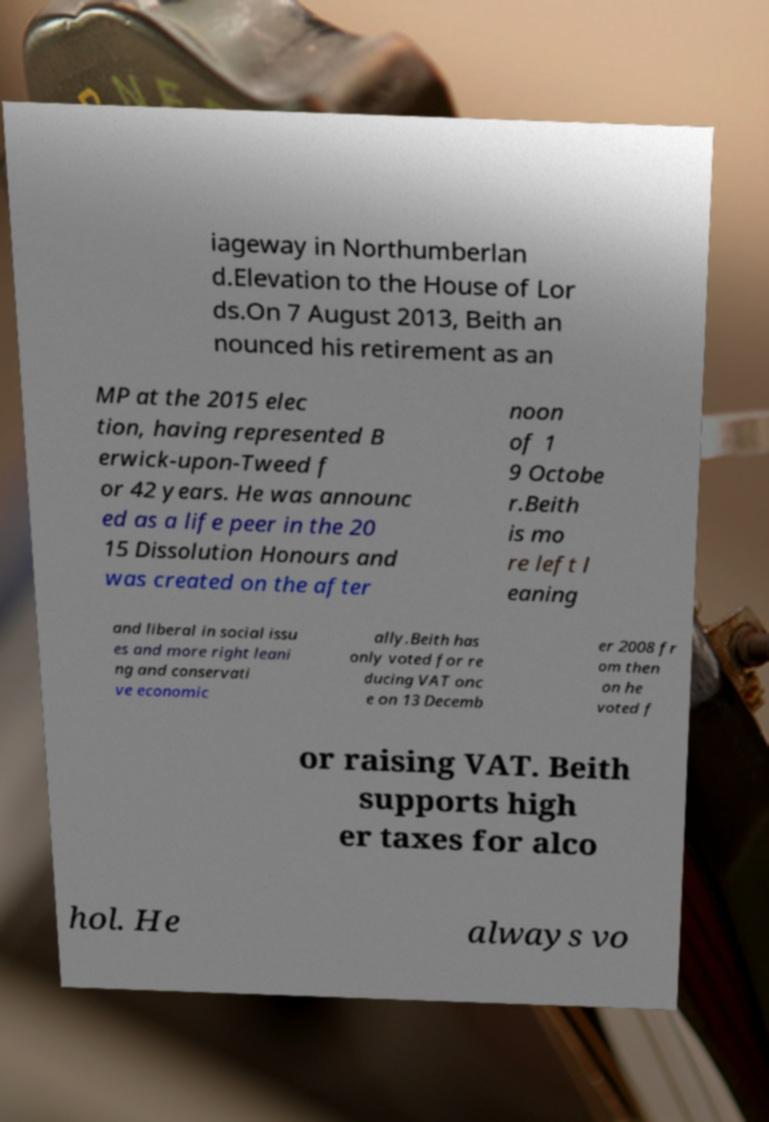I need the written content from this picture converted into text. Can you do that? iageway in Northumberlan d.Elevation to the House of Lor ds.On 7 August 2013, Beith an nounced his retirement as an MP at the 2015 elec tion, having represented B erwick-upon-Tweed f or 42 years. He was announc ed as a life peer in the 20 15 Dissolution Honours and was created on the after noon of 1 9 Octobe r.Beith is mo re left l eaning and liberal in social issu es and more right leani ng and conservati ve economic ally.Beith has only voted for re ducing VAT onc e on 13 Decemb er 2008 fr om then on he voted f or raising VAT. Beith supports high er taxes for alco hol. He always vo 